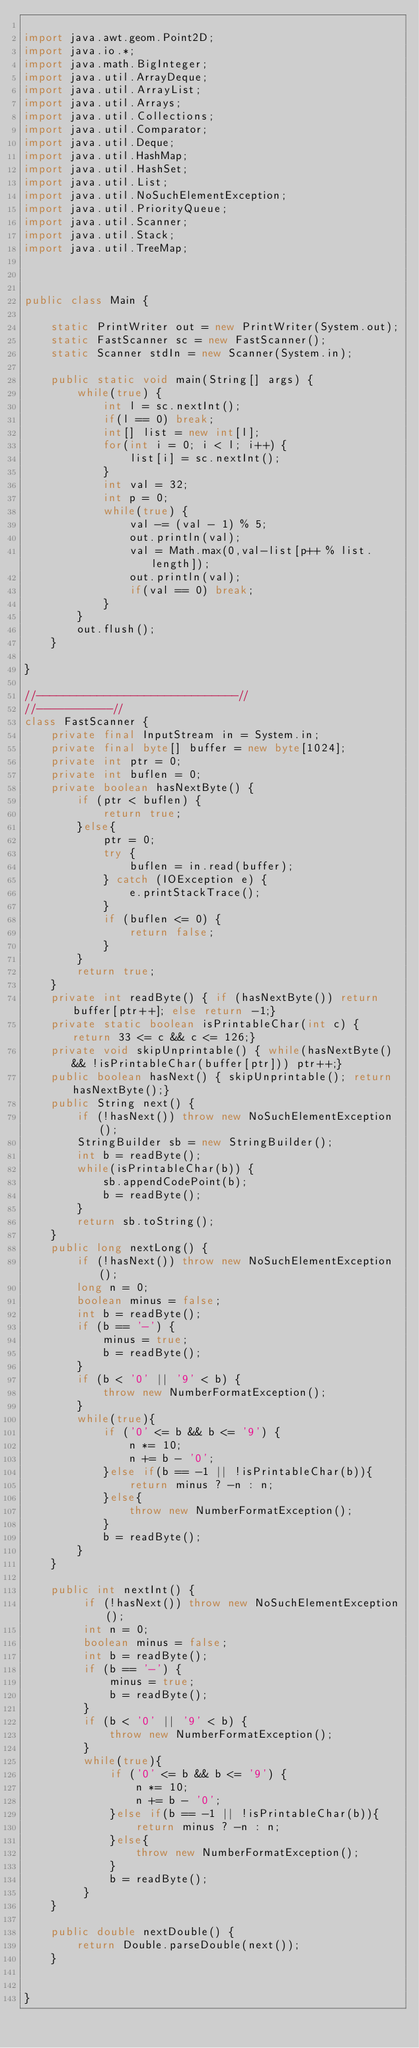<code> <loc_0><loc_0><loc_500><loc_500><_Java_>
import java.awt.geom.Point2D;
import java.io.*;
import java.math.BigInteger;
import java.util.ArrayDeque;
import java.util.ArrayList;
import java.util.Arrays;
import java.util.Collections;
import java.util.Comparator;
import java.util.Deque;
import java.util.HashMap;
import java.util.HashSet;
import java.util.List;
import java.util.NoSuchElementException;
import java.util.PriorityQueue;
import java.util.Scanner;
import java.util.Stack;
import java.util.TreeMap;



public class Main {

	static PrintWriter out = new PrintWriter(System.out);
	static FastScanner sc = new FastScanner();
	static Scanner stdIn = new Scanner(System.in);

	public static void main(String[] args) {
		while(true) {
			int l = sc.nextInt();
			if(l == 0) break;
			int[] list = new int[l];
			for(int i = 0; i < l; i++) {
				list[i] = sc.nextInt();
			}
			int val = 32;
			int p = 0;
			while(true) {
				val -= (val - 1) % 5;
				out.println(val);
				val = Math.max(0,val-list[p++ % list.length]);
				out.println(val);
				if(val == 0) break;
			}
		}
		out.flush();
	}

}

//------------------------------//
//-----------//
class FastScanner {
    private final InputStream in = System.in;
    private final byte[] buffer = new byte[1024];
    private int ptr = 0;
    private int buflen = 0;
    private boolean hasNextByte() {
        if (ptr < buflen) {
            return true;
        }else{
            ptr = 0;
            try {
                buflen = in.read(buffer);
            } catch (IOException e) {
                e.printStackTrace();
            }
            if (buflen <= 0) {
                return false;
            }
        }
        return true;
    }
    private int readByte() { if (hasNextByte()) return buffer[ptr++]; else return -1;}
    private static boolean isPrintableChar(int c) { return 33 <= c && c <= 126;}
    private void skipUnprintable() { while(hasNextByte() && !isPrintableChar(buffer[ptr])) ptr++;}
    public boolean hasNext() { skipUnprintable(); return hasNextByte();}
    public String next() {
        if (!hasNext()) throw new NoSuchElementException();
        StringBuilder sb = new StringBuilder();
        int b = readByte();
        while(isPrintableChar(b)) {
            sb.appendCodePoint(b);
            b = readByte();
        }
        return sb.toString();
    }
    public long nextLong() {
        if (!hasNext()) throw new NoSuchElementException();
        long n = 0;
        boolean minus = false;
        int b = readByte();
        if (b == '-') {
            minus = true;
            b = readByte();
        }
        if (b < '0' || '9' < b) {
            throw new NumberFormatException();
        }
        while(true){
            if ('0' <= b && b <= '9') {
                n *= 10;
                n += b - '0';
            }else if(b == -1 || !isPrintableChar(b)){
                return minus ? -n : n;
            }else{
                throw new NumberFormatException();
            }
            b = readByte();
        }
    }
    
    public int nextInt() {
    	 if (!hasNext()) throw new NoSuchElementException();
         int n = 0;
         boolean minus = false;
         int b = readByte();
         if (b == '-') {
             minus = true;
             b = readByte();
         }
         if (b < '0' || '9' < b) {
             throw new NumberFormatException();
         }
         while(true){
             if ('0' <= b && b <= '9') {
                 n *= 10;
                 n += b - '0';
             }else if(b == -1 || !isPrintableChar(b)){
                 return minus ? -n : n;
             }else{
                 throw new NumberFormatException();
             }
             b = readByte();
         }
    }
    
    public double nextDouble() {
    	return Double.parseDouble(next());
    }
    

}</code> 